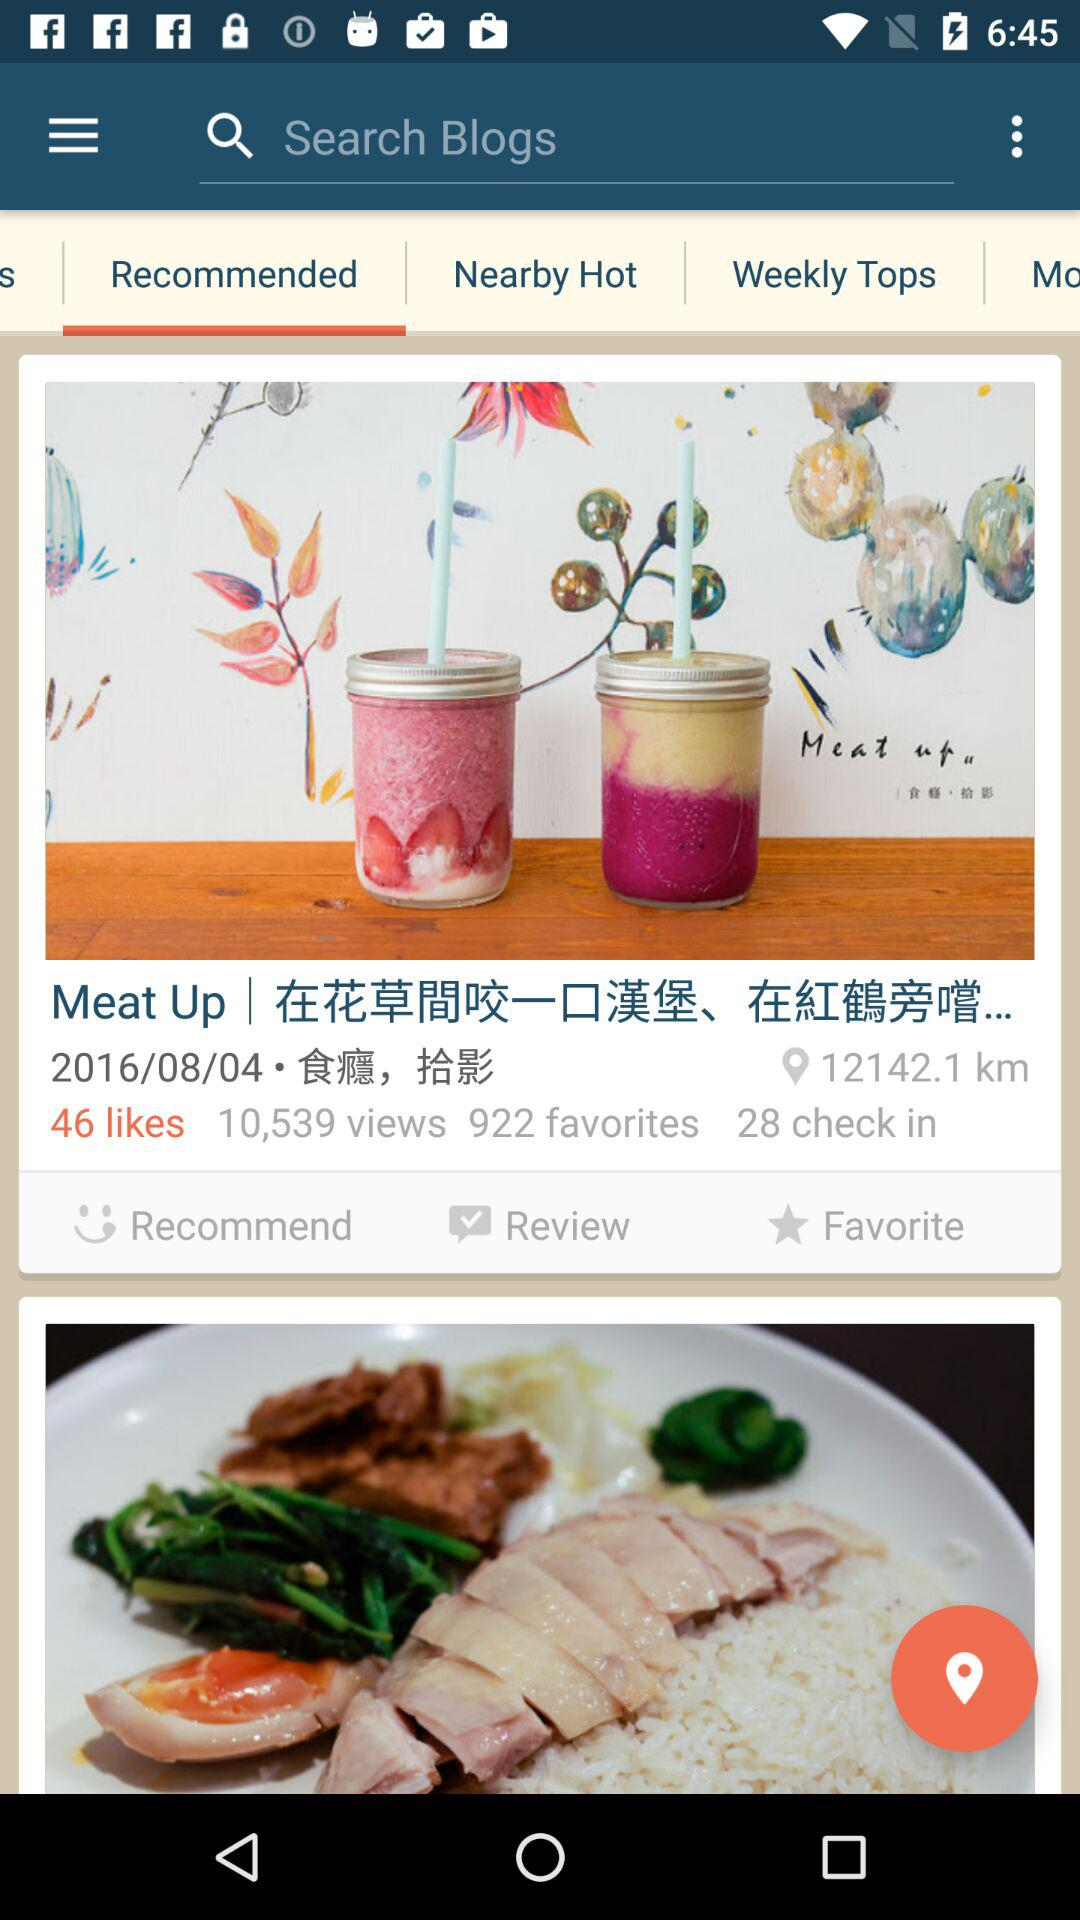How many favorites are there for the first item?
Answer the question using a single word or phrase. 922 